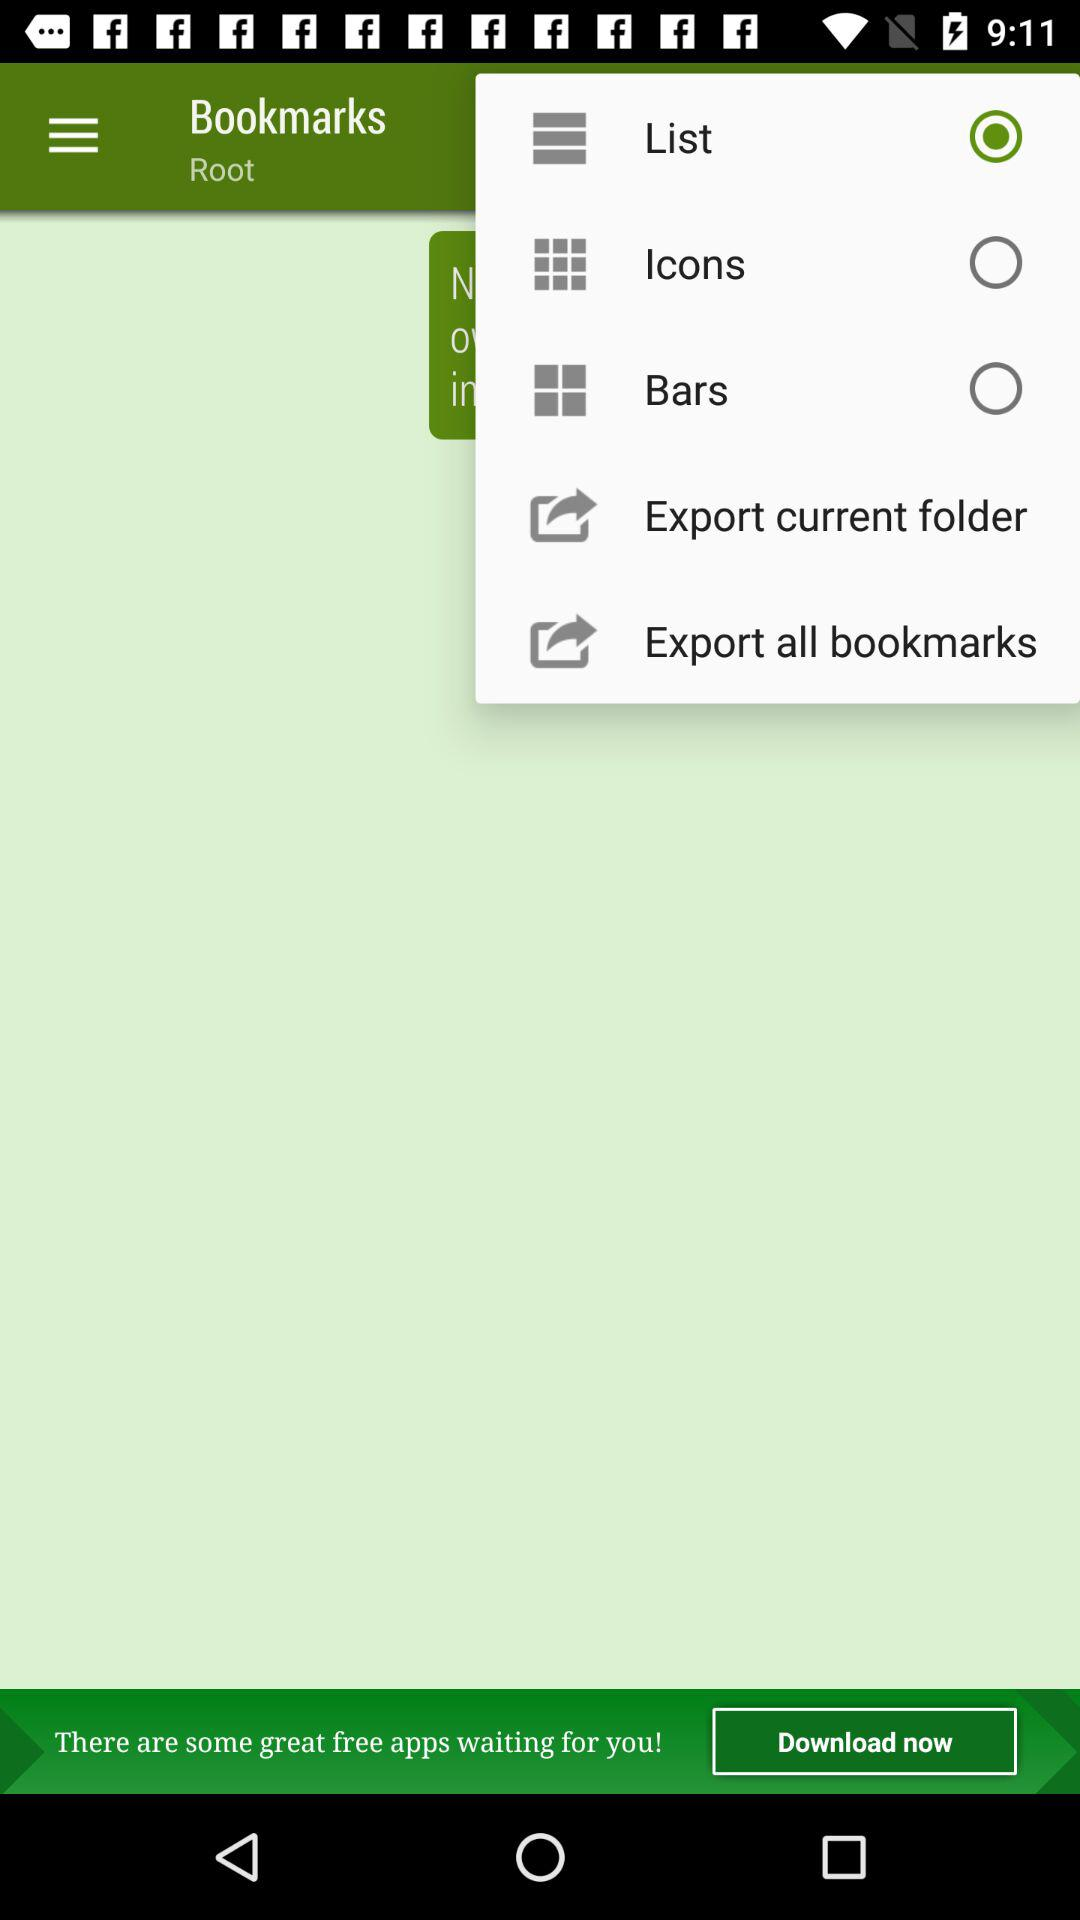Is "List" selected or not?
Answer the question using a single word or phrase. "List" is selected. 